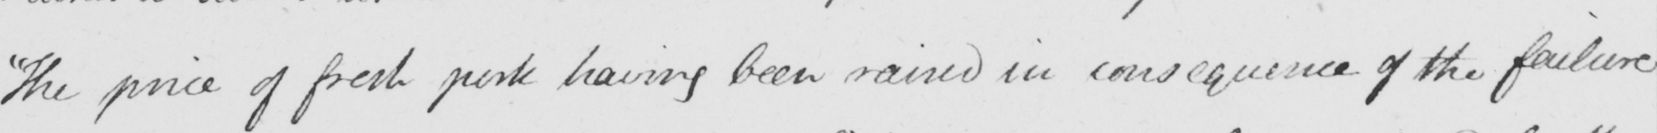Can you read and transcribe this handwriting? The price of fresh pork having been raised in consequence of the failure 